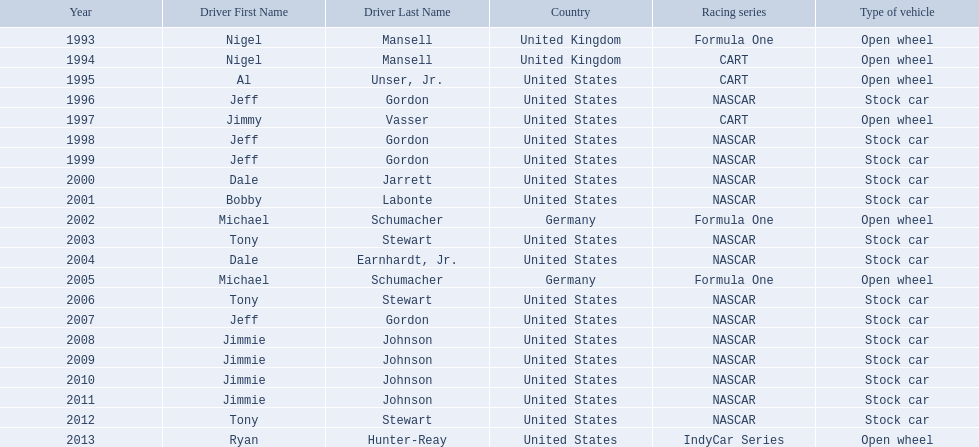Which drivers have won the best driver espy award? Nigel Mansell, Nigel Mansell, Al Unser, Jr., Jeff Gordon, Jimmy Vasser, Jeff Gordon, Jeff Gordon, Dale Jarrett, Bobby Labonte, Michael Schumacher, Tony Stewart, Dale Earnhardt, Jr., Michael Schumacher, Tony Stewart, Jeff Gordon, Jimmie Johnson, Jimmie Johnson, Jimmie Johnson, Jimmie Johnson, Tony Stewart, Ryan Hunter-Reay. Of these, which only appear once? Al Unser, Jr., Jimmy Vasser, Dale Jarrett, Dale Earnhardt, Jr., Ryan Hunter-Reay. Which of these are from the cart racing series? Al Unser, Jr., Jimmy Vasser. Of these, which received their award first? Al Unser, Jr. 